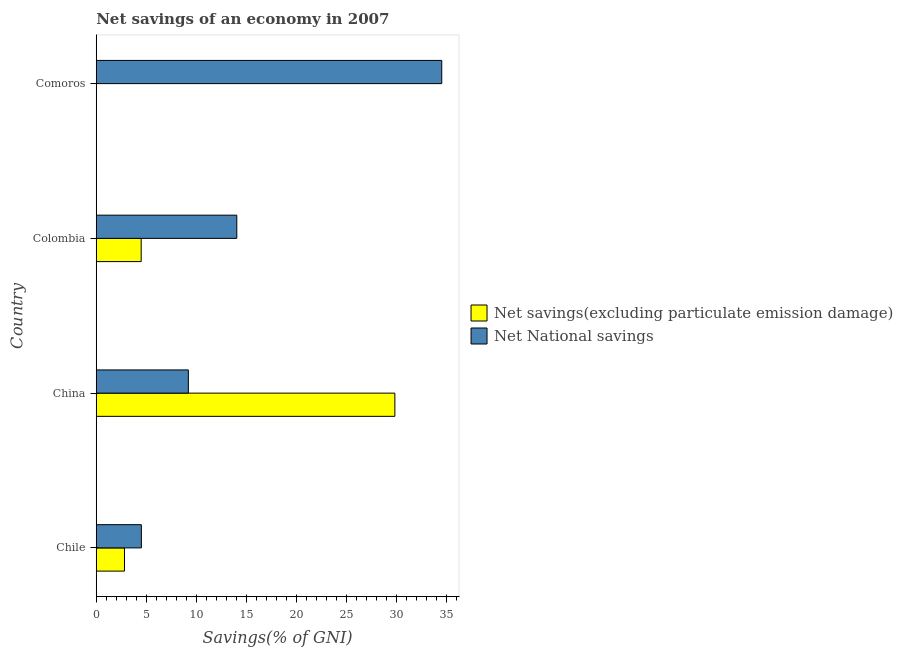How many different coloured bars are there?
Offer a terse response. 2. Are the number of bars on each tick of the Y-axis equal?
Provide a succinct answer. No. How many bars are there on the 2nd tick from the bottom?
Provide a succinct answer. 2. In how many cases, is the number of bars for a given country not equal to the number of legend labels?
Make the answer very short. 1. What is the net savings(excluding particulate emission damage) in Comoros?
Provide a succinct answer. 0. Across all countries, what is the maximum net national savings?
Provide a succinct answer. 34.52. In which country was the net national savings maximum?
Your answer should be very brief. Comoros. What is the total net savings(excluding particulate emission damage) in the graph?
Offer a terse response. 37.15. What is the difference between the net savings(excluding particulate emission damage) in Chile and that in Colombia?
Make the answer very short. -1.67. What is the difference between the net savings(excluding particulate emission damage) in Comoros and the net national savings in Chile?
Provide a short and direct response. -4.51. What is the average net national savings per country?
Give a very brief answer. 15.57. What is the difference between the net national savings and net savings(excluding particulate emission damage) in China?
Offer a terse response. -20.63. What is the ratio of the net national savings in Chile to that in China?
Your answer should be very brief. 0.49. Is the difference between the net savings(excluding particulate emission damage) in China and Colombia greater than the difference between the net national savings in China and Colombia?
Make the answer very short. Yes. What is the difference between the highest and the second highest net national savings?
Offer a terse response. 20.48. What is the difference between the highest and the lowest net national savings?
Offer a very short reply. 30.02. In how many countries, is the net savings(excluding particulate emission damage) greater than the average net savings(excluding particulate emission damage) taken over all countries?
Provide a short and direct response. 1. How many bars are there?
Give a very brief answer. 7. Are all the bars in the graph horizontal?
Keep it short and to the point. Yes. Does the graph contain any zero values?
Provide a short and direct response. Yes. Does the graph contain grids?
Give a very brief answer. No. Where does the legend appear in the graph?
Make the answer very short. Center right. How many legend labels are there?
Provide a short and direct response. 2. How are the legend labels stacked?
Give a very brief answer. Vertical. What is the title of the graph?
Keep it short and to the point. Net savings of an economy in 2007. What is the label or title of the X-axis?
Your response must be concise. Savings(% of GNI). What is the label or title of the Y-axis?
Give a very brief answer. Country. What is the Savings(% of GNI) of Net savings(excluding particulate emission damage) in Chile?
Ensure brevity in your answer.  2.82. What is the Savings(% of GNI) of Net National savings in Chile?
Your answer should be compact. 4.51. What is the Savings(% of GNI) in Net savings(excluding particulate emission damage) in China?
Ensure brevity in your answer.  29.84. What is the Savings(% of GNI) of Net National savings in China?
Give a very brief answer. 9.2. What is the Savings(% of GNI) of Net savings(excluding particulate emission damage) in Colombia?
Offer a very short reply. 4.49. What is the Savings(% of GNI) of Net National savings in Colombia?
Ensure brevity in your answer.  14.04. What is the Savings(% of GNI) of Net savings(excluding particulate emission damage) in Comoros?
Your answer should be very brief. 0. What is the Savings(% of GNI) in Net National savings in Comoros?
Your response must be concise. 34.52. Across all countries, what is the maximum Savings(% of GNI) of Net savings(excluding particulate emission damage)?
Your answer should be compact. 29.84. Across all countries, what is the maximum Savings(% of GNI) in Net National savings?
Your answer should be compact. 34.52. Across all countries, what is the minimum Savings(% of GNI) in Net National savings?
Keep it short and to the point. 4.51. What is the total Savings(% of GNI) of Net savings(excluding particulate emission damage) in the graph?
Provide a short and direct response. 37.15. What is the total Savings(% of GNI) of Net National savings in the graph?
Your response must be concise. 62.27. What is the difference between the Savings(% of GNI) of Net savings(excluding particulate emission damage) in Chile and that in China?
Your answer should be very brief. -27.02. What is the difference between the Savings(% of GNI) in Net National savings in Chile and that in China?
Provide a short and direct response. -4.7. What is the difference between the Savings(% of GNI) of Net savings(excluding particulate emission damage) in Chile and that in Colombia?
Make the answer very short. -1.67. What is the difference between the Savings(% of GNI) of Net National savings in Chile and that in Colombia?
Ensure brevity in your answer.  -9.54. What is the difference between the Savings(% of GNI) of Net National savings in Chile and that in Comoros?
Keep it short and to the point. -30.02. What is the difference between the Savings(% of GNI) of Net savings(excluding particulate emission damage) in China and that in Colombia?
Your answer should be very brief. 25.35. What is the difference between the Savings(% of GNI) of Net National savings in China and that in Colombia?
Your response must be concise. -4.84. What is the difference between the Savings(% of GNI) of Net National savings in China and that in Comoros?
Offer a terse response. -25.32. What is the difference between the Savings(% of GNI) of Net National savings in Colombia and that in Comoros?
Give a very brief answer. -20.48. What is the difference between the Savings(% of GNI) of Net savings(excluding particulate emission damage) in Chile and the Savings(% of GNI) of Net National savings in China?
Offer a very short reply. -6.38. What is the difference between the Savings(% of GNI) of Net savings(excluding particulate emission damage) in Chile and the Savings(% of GNI) of Net National savings in Colombia?
Ensure brevity in your answer.  -11.22. What is the difference between the Savings(% of GNI) in Net savings(excluding particulate emission damage) in Chile and the Savings(% of GNI) in Net National savings in Comoros?
Your answer should be very brief. -31.7. What is the difference between the Savings(% of GNI) in Net savings(excluding particulate emission damage) in China and the Savings(% of GNI) in Net National savings in Colombia?
Provide a short and direct response. 15.79. What is the difference between the Savings(% of GNI) in Net savings(excluding particulate emission damage) in China and the Savings(% of GNI) in Net National savings in Comoros?
Provide a succinct answer. -4.68. What is the difference between the Savings(% of GNI) in Net savings(excluding particulate emission damage) in Colombia and the Savings(% of GNI) in Net National savings in Comoros?
Keep it short and to the point. -30.03. What is the average Savings(% of GNI) of Net savings(excluding particulate emission damage) per country?
Provide a short and direct response. 9.29. What is the average Savings(% of GNI) of Net National savings per country?
Offer a very short reply. 15.57. What is the difference between the Savings(% of GNI) in Net savings(excluding particulate emission damage) and Savings(% of GNI) in Net National savings in Chile?
Make the answer very short. -1.69. What is the difference between the Savings(% of GNI) in Net savings(excluding particulate emission damage) and Savings(% of GNI) in Net National savings in China?
Your answer should be compact. 20.63. What is the difference between the Savings(% of GNI) in Net savings(excluding particulate emission damage) and Savings(% of GNI) in Net National savings in Colombia?
Ensure brevity in your answer.  -9.55. What is the ratio of the Savings(% of GNI) of Net savings(excluding particulate emission damage) in Chile to that in China?
Offer a terse response. 0.09. What is the ratio of the Savings(% of GNI) in Net National savings in Chile to that in China?
Your response must be concise. 0.49. What is the ratio of the Savings(% of GNI) of Net savings(excluding particulate emission damage) in Chile to that in Colombia?
Offer a very short reply. 0.63. What is the ratio of the Savings(% of GNI) of Net National savings in Chile to that in Colombia?
Offer a terse response. 0.32. What is the ratio of the Savings(% of GNI) in Net National savings in Chile to that in Comoros?
Offer a very short reply. 0.13. What is the ratio of the Savings(% of GNI) of Net savings(excluding particulate emission damage) in China to that in Colombia?
Your answer should be very brief. 6.65. What is the ratio of the Savings(% of GNI) of Net National savings in China to that in Colombia?
Provide a short and direct response. 0.66. What is the ratio of the Savings(% of GNI) of Net National savings in China to that in Comoros?
Ensure brevity in your answer.  0.27. What is the ratio of the Savings(% of GNI) of Net National savings in Colombia to that in Comoros?
Your response must be concise. 0.41. What is the difference between the highest and the second highest Savings(% of GNI) of Net savings(excluding particulate emission damage)?
Your response must be concise. 25.35. What is the difference between the highest and the second highest Savings(% of GNI) of Net National savings?
Offer a terse response. 20.48. What is the difference between the highest and the lowest Savings(% of GNI) of Net savings(excluding particulate emission damage)?
Provide a succinct answer. 29.84. What is the difference between the highest and the lowest Savings(% of GNI) in Net National savings?
Provide a short and direct response. 30.02. 